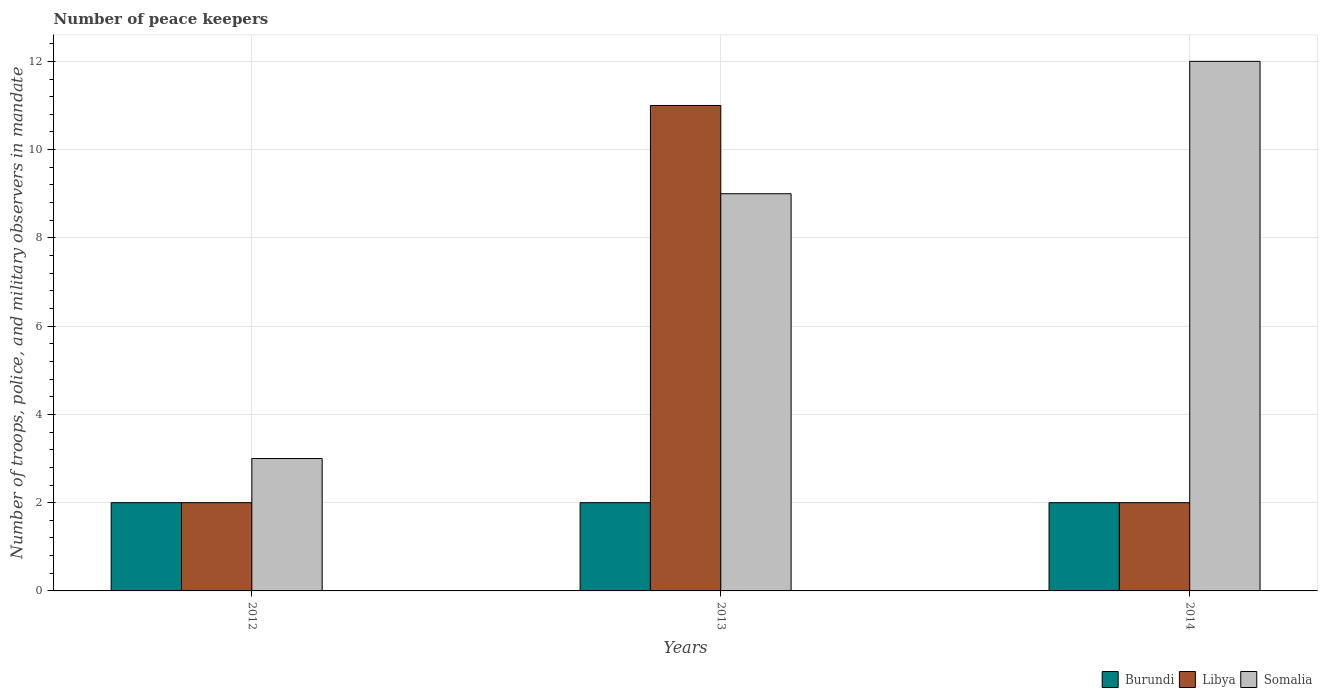Are the number of bars per tick equal to the number of legend labels?
Keep it short and to the point. Yes. In how many cases, is the number of bars for a given year not equal to the number of legend labels?
Give a very brief answer. 0. Across all years, what is the maximum number of peace keepers in in Burundi?
Your response must be concise. 2. In which year was the number of peace keepers in in Burundi maximum?
Offer a terse response. 2012. In which year was the number of peace keepers in in Burundi minimum?
Offer a terse response. 2012. What is the average number of peace keepers in in Burundi per year?
Offer a very short reply. 2. In how many years, is the number of peace keepers in in Somalia greater than 0.4?
Your answer should be very brief. 3. What is the ratio of the number of peace keepers in in Somalia in 2012 to that in 2013?
Provide a short and direct response. 0.33. What is the difference between the highest and the second highest number of peace keepers in in Libya?
Offer a very short reply. 9. What is the difference between the highest and the lowest number of peace keepers in in Libya?
Your answer should be compact. 9. What does the 2nd bar from the left in 2012 represents?
Keep it short and to the point. Libya. What does the 2nd bar from the right in 2014 represents?
Offer a terse response. Libya. Are all the bars in the graph horizontal?
Offer a very short reply. No. What is the difference between two consecutive major ticks on the Y-axis?
Keep it short and to the point. 2. Are the values on the major ticks of Y-axis written in scientific E-notation?
Offer a very short reply. No. How many legend labels are there?
Offer a very short reply. 3. What is the title of the graph?
Your answer should be compact. Number of peace keepers. Does "Chile" appear as one of the legend labels in the graph?
Provide a succinct answer. No. What is the label or title of the X-axis?
Offer a terse response. Years. What is the label or title of the Y-axis?
Ensure brevity in your answer.  Number of troops, police, and military observers in mandate. What is the Number of troops, police, and military observers in mandate of Burundi in 2012?
Keep it short and to the point. 2. What is the Number of troops, police, and military observers in mandate of Libya in 2012?
Provide a short and direct response. 2. What is the Number of troops, police, and military observers in mandate in Libya in 2013?
Keep it short and to the point. 11. What is the Number of troops, police, and military observers in mandate in Burundi in 2014?
Keep it short and to the point. 2. Across all years, what is the maximum Number of troops, police, and military observers in mandate of Somalia?
Your answer should be compact. 12. Across all years, what is the minimum Number of troops, police, and military observers in mandate in Somalia?
Your answer should be very brief. 3. What is the difference between the Number of troops, police, and military observers in mandate of Libya in 2012 and that in 2013?
Provide a succinct answer. -9. What is the difference between the Number of troops, police, and military observers in mandate in Burundi in 2012 and that in 2014?
Provide a short and direct response. 0. What is the difference between the Number of troops, police, and military observers in mandate of Libya in 2012 and that in 2014?
Your answer should be compact. 0. What is the difference between the Number of troops, police, and military observers in mandate in Somalia in 2012 and that in 2014?
Your response must be concise. -9. What is the difference between the Number of troops, police, and military observers in mandate in Somalia in 2013 and that in 2014?
Your response must be concise. -3. What is the difference between the Number of troops, police, and military observers in mandate of Burundi in 2012 and the Number of troops, police, and military observers in mandate of Libya in 2013?
Give a very brief answer. -9. What is the difference between the Number of troops, police, and military observers in mandate of Burundi in 2012 and the Number of troops, police, and military observers in mandate of Somalia in 2013?
Your answer should be compact. -7. What is the difference between the Number of troops, police, and military observers in mandate in Burundi in 2012 and the Number of troops, police, and military observers in mandate in Libya in 2014?
Offer a terse response. 0. What is the difference between the Number of troops, police, and military observers in mandate in Libya in 2012 and the Number of troops, police, and military observers in mandate in Somalia in 2014?
Offer a terse response. -10. What is the difference between the Number of troops, police, and military observers in mandate in Burundi in 2013 and the Number of troops, police, and military observers in mandate in Somalia in 2014?
Keep it short and to the point. -10. What is the average Number of troops, police, and military observers in mandate in Burundi per year?
Ensure brevity in your answer.  2. What is the average Number of troops, police, and military observers in mandate in Somalia per year?
Offer a very short reply. 8. In the year 2012, what is the difference between the Number of troops, police, and military observers in mandate in Burundi and Number of troops, police, and military observers in mandate in Libya?
Offer a terse response. 0. In the year 2012, what is the difference between the Number of troops, police, and military observers in mandate in Libya and Number of troops, police, and military observers in mandate in Somalia?
Offer a terse response. -1. In the year 2013, what is the difference between the Number of troops, police, and military observers in mandate of Burundi and Number of troops, police, and military observers in mandate of Libya?
Your answer should be compact. -9. In the year 2013, what is the difference between the Number of troops, police, and military observers in mandate in Burundi and Number of troops, police, and military observers in mandate in Somalia?
Provide a succinct answer. -7. What is the ratio of the Number of troops, police, and military observers in mandate of Libya in 2012 to that in 2013?
Make the answer very short. 0.18. What is the ratio of the Number of troops, police, and military observers in mandate in Somalia in 2012 to that in 2013?
Your response must be concise. 0.33. What is the ratio of the Number of troops, police, and military observers in mandate in Somalia in 2012 to that in 2014?
Provide a short and direct response. 0.25. What is the ratio of the Number of troops, police, and military observers in mandate of Libya in 2013 to that in 2014?
Keep it short and to the point. 5.5. What is the ratio of the Number of troops, police, and military observers in mandate in Somalia in 2013 to that in 2014?
Offer a very short reply. 0.75. What is the difference between the highest and the second highest Number of troops, police, and military observers in mandate of Burundi?
Keep it short and to the point. 0. What is the difference between the highest and the second highest Number of troops, police, and military observers in mandate in Libya?
Your response must be concise. 9. What is the difference between the highest and the lowest Number of troops, police, and military observers in mandate of Burundi?
Make the answer very short. 0. What is the difference between the highest and the lowest Number of troops, police, and military observers in mandate of Somalia?
Provide a short and direct response. 9. 